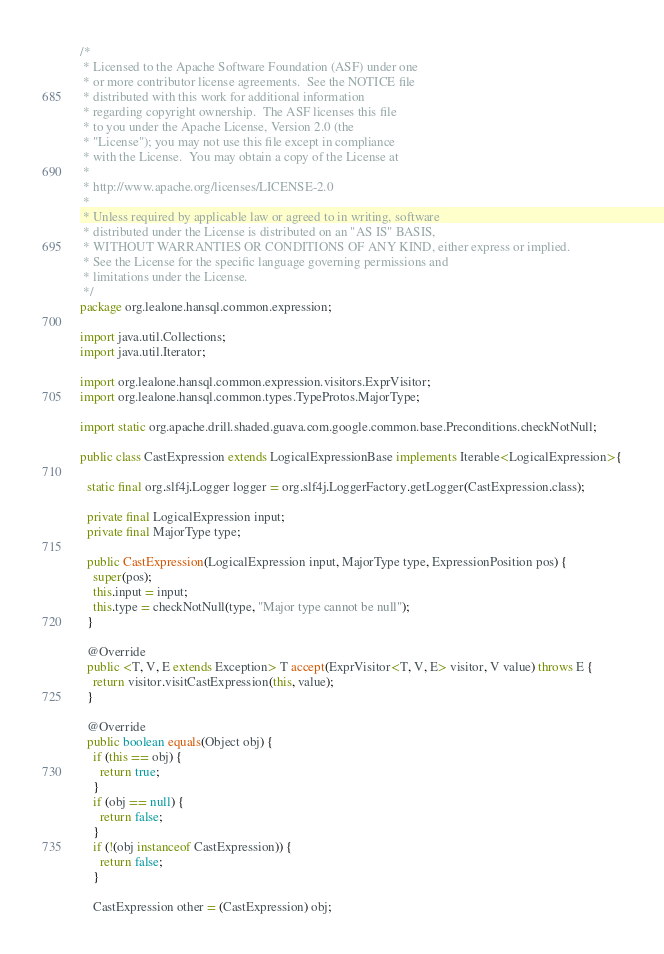<code> <loc_0><loc_0><loc_500><loc_500><_Java_>/*
 * Licensed to the Apache Software Foundation (ASF) under one
 * or more contributor license agreements.  See the NOTICE file
 * distributed with this work for additional information
 * regarding copyright ownership.  The ASF licenses this file
 * to you under the Apache License, Version 2.0 (the
 * "License"); you may not use this file except in compliance
 * with the License.  You may obtain a copy of the License at
 *
 * http://www.apache.org/licenses/LICENSE-2.0
 *
 * Unless required by applicable law or agreed to in writing, software
 * distributed under the License is distributed on an "AS IS" BASIS,
 * WITHOUT WARRANTIES OR CONDITIONS OF ANY KIND, either express or implied.
 * See the License for the specific language governing permissions and
 * limitations under the License.
 */
package org.lealone.hansql.common.expression;

import java.util.Collections;
import java.util.Iterator;

import org.lealone.hansql.common.expression.visitors.ExprVisitor;
import org.lealone.hansql.common.types.TypeProtos.MajorType;

import static org.apache.drill.shaded.guava.com.google.common.base.Preconditions.checkNotNull;

public class CastExpression extends LogicalExpressionBase implements Iterable<LogicalExpression>{

  static final org.slf4j.Logger logger = org.slf4j.LoggerFactory.getLogger(CastExpression.class);

  private final LogicalExpression input;
  private final MajorType type;

  public CastExpression(LogicalExpression input, MajorType type, ExpressionPosition pos) {
    super(pos);
    this.input = input;
    this.type = checkNotNull(type, "Major type cannot be null");
  }

  @Override
  public <T, V, E extends Exception> T accept(ExprVisitor<T, V, E> visitor, V value) throws E {
    return visitor.visitCastExpression(this, value);
  }

  @Override
  public boolean equals(Object obj) {
    if (this == obj) {
      return true;
    }
    if (obj == null) {
      return false;
    }
    if (!(obj instanceof CastExpression)) {
      return false;
    }

    CastExpression other = (CastExpression) obj;
</code> 